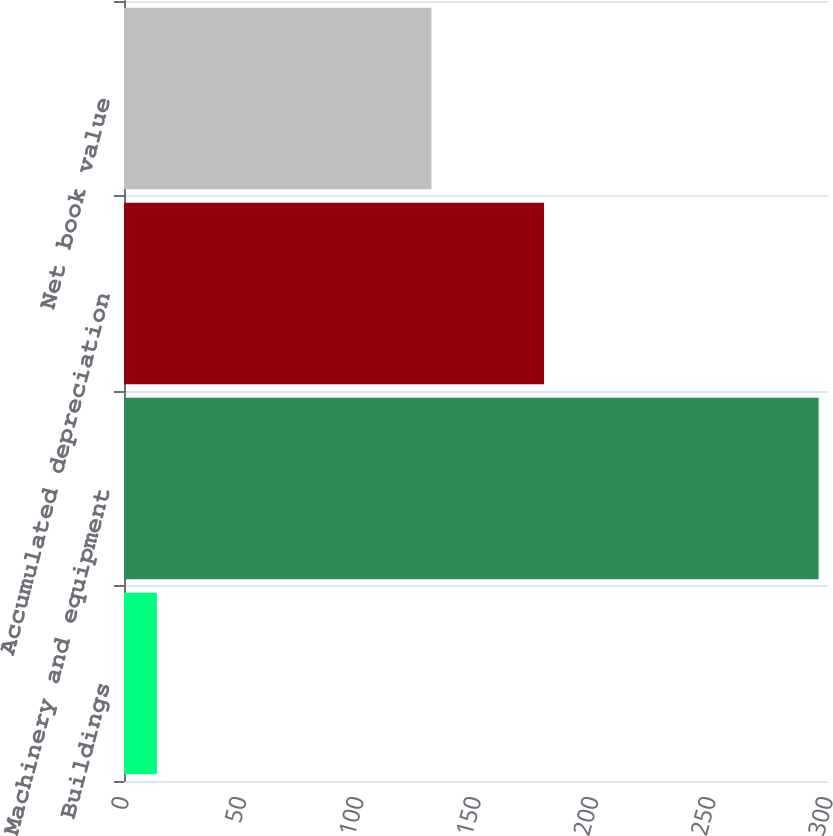Convert chart. <chart><loc_0><loc_0><loc_500><loc_500><bar_chart><fcel>Buildings<fcel>Machinery and equipment<fcel>Accumulated depreciation<fcel>Net book value<nl><fcel>14<fcel>296<fcel>179<fcel>131<nl></chart> 